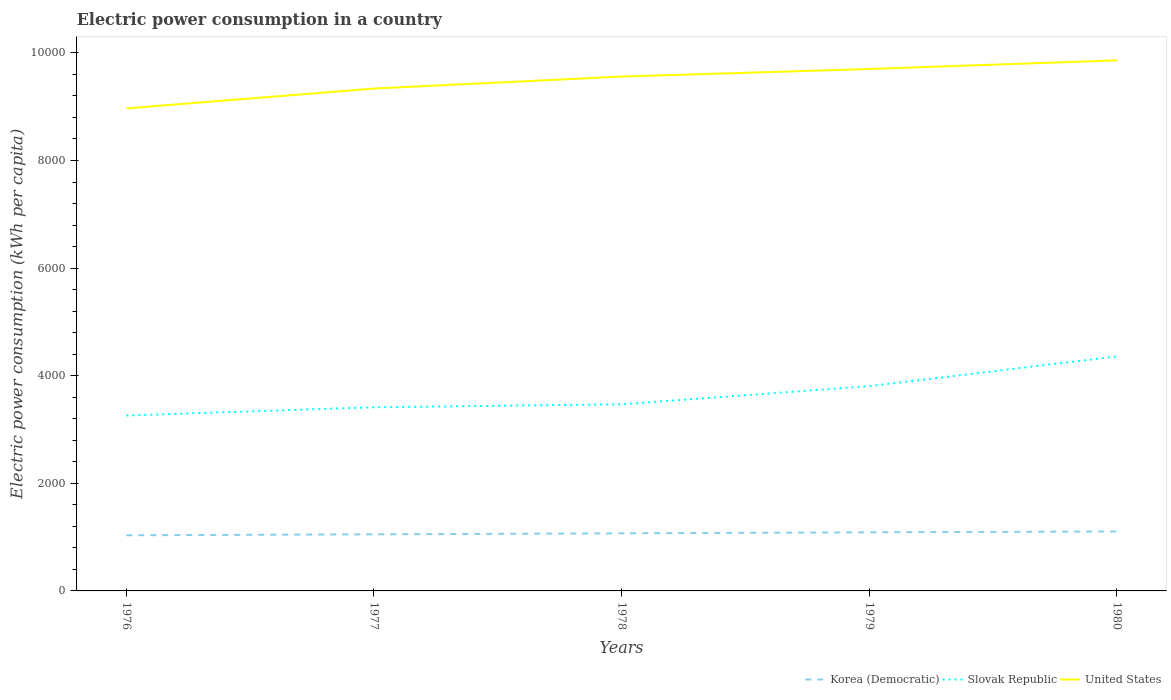How many different coloured lines are there?
Provide a succinct answer. 3. Across all years, what is the maximum electric power consumption in in Slovak Republic?
Your answer should be very brief. 3260.46. In which year was the electric power consumption in in Slovak Republic maximum?
Offer a very short reply. 1976. What is the total electric power consumption in in United States in the graph?
Provide a succinct answer. -368.95. What is the difference between the highest and the second highest electric power consumption in in Korea (Democratic)?
Give a very brief answer. 71.05. Is the electric power consumption in in Korea (Democratic) strictly greater than the electric power consumption in in United States over the years?
Offer a very short reply. Yes. Where does the legend appear in the graph?
Your answer should be compact. Bottom right. What is the title of the graph?
Offer a very short reply. Electric power consumption in a country. What is the label or title of the X-axis?
Your answer should be compact. Years. What is the label or title of the Y-axis?
Your answer should be very brief. Electric power consumption (kWh per capita). What is the Electric power consumption (kWh per capita) in Korea (Democratic) in 1976?
Provide a succinct answer. 1034.22. What is the Electric power consumption (kWh per capita) in Slovak Republic in 1976?
Offer a very short reply. 3260.46. What is the Electric power consumption (kWh per capita) in United States in 1976?
Provide a short and direct response. 8968.78. What is the Electric power consumption (kWh per capita) of Korea (Democratic) in 1977?
Your answer should be very brief. 1052.04. What is the Electric power consumption (kWh per capita) of Slovak Republic in 1977?
Offer a terse response. 3413.49. What is the Electric power consumption (kWh per capita) in United States in 1977?
Provide a succinct answer. 9337.72. What is the Electric power consumption (kWh per capita) in Korea (Democratic) in 1978?
Offer a terse response. 1070.92. What is the Electric power consumption (kWh per capita) in Slovak Republic in 1978?
Your response must be concise. 3468.62. What is the Electric power consumption (kWh per capita) in United States in 1978?
Your answer should be very brief. 9560.55. What is the Electric power consumption (kWh per capita) of Korea (Democratic) in 1979?
Offer a terse response. 1089.3. What is the Electric power consumption (kWh per capita) in Slovak Republic in 1979?
Ensure brevity in your answer.  3806.46. What is the Electric power consumption (kWh per capita) in United States in 1979?
Make the answer very short. 9700.7. What is the Electric power consumption (kWh per capita) in Korea (Democratic) in 1980?
Ensure brevity in your answer.  1105.27. What is the Electric power consumption (kWh per capita) in Slovak Republic in 1980?
Offer a terse response. 4358.6. What is the Electric power consumption (kWh per capita) of United States in 1980?
Ensure brevity in your answer.  9862.37. Across all years, what is the maximum Electric power consumption (kWh per capita) of Korea (Democratic)?
Provide a succinct answer. 1105.27. Across all years, what is the maximum Electric power consumption (kWh per capita) of Slovak Republic?
Keep it short and to the point. 4358.6. Across all years, what is the maximum Electric power consumption (kWh per capita) of United States?
Your answer should be very brief. 9862.37. Across all years, what is the minimum Electric power consumption (kWh per capita) in Korea (Democratic)?
Ensure brevity in your answer.  1034.22. Across all years, what is the minimum Electric power consumption (kWh per capita) of Slovak Republic?
Make the answer very short. 3260.46. Across all years, what is the minimum Electric power consumption (kWh per capita) of United States?
Keep it short and to the point. 8968.78. What is the total Electric power consumption (kWh per capita) of Korea (Democratic) in the graph?
Make the answer very short. 5351.76. What is the total Electric power consumption (kWh per capita) in Slovak Republic in the graph?
Provide a succinct answer. 1.83e+04. What is the total Electric power consumption (kWh per capita) in United States in the graph?
Offer a terse response. 4.74e+04. What is the difference between the Electric power consumption (kWh per capita) of Korea (Democratic) in 1976 and that in 1977?
Keep it short and to the point. -17.82. What is the difference between the Electric power consumption (kWh per capita) in Slovak Republic in 1976 and that in 1977?
Provide a succinct answer. -153.03. What is the difference between the Electric power consumption (kWh per capita) in United States in 1976 and that in 1977?
Provide a succinct answer. -368.95. What is the difference between the Electric power consumption (kWh per capita) in Korea (Democratic) in 1976 and that in 1978?
Ensure brevity in your answer.  -36.7. What is the difference between the Electric power consumption (kWh per capita) in Slovak Republic in 1976 and that in 1978?
Your answer should be compact. -208.16. What is the difference between the Electric power consumption (kWh per capita) in United States in 1976 and that in 1978?
Offer a terse response. -591.77. What is the difference between the Electric power consumption (kWh per capita) of Korea (Democratic) in 1976 and that in 1979?
Offer a very short reply. -55.08. What is the difference between the Electric power consumption (kWh per capita) of Slovak Republic in 1976 and that in 1979?
Offer a terse response. -546. What is the difference between the Electric power consumption (kWh per capita) of United States in 1976 and that in 1979?
Make the answer very short. -731.92. What is the difference between the Electric power consumption (kWh per capita) of Korea (Democratic) in 1976 and that in 1980?
Offer a terse response. -71.05. What is the difference between the Electric power consumption (kWh per capita) of Slovak Republic in 1976 and that in 1980?
Offer a terse response. -1098.13. What is the difference between the Electric power consumption (kWh per capita) in United States in 1976 and that in 1980?
Ensure brevity in your answer.  -893.59. What is the difference between the Electric power consumption (kWh per capita) of Korea (Democratic) in 1977 and that in 1978?
Keep it short and to the point. -18.88. What is the difference between the Electric power consumption (kWh per capita) in Slovak Republic in 1977 and that in 1978?
Ensure brevity in your answer.  -55.13. What is the difference between the Electric power consumption (kWh per capita) of United States in 1977 and that in 1978?
Your answer should be very brief. -222.82. What is the difference between the Electric power consumption (kWh per capita) of Korea (Democratic) in 1977 and that in 1979?
Keep it short and to the point. -37.26. What is the difference between the Electric power consumption (kWh per capita) in Slovak Republic in 1977 and that in 1979?
Ensure brevity in your answer.  -392.97. What is the difference between the Electric power consumption (kWh per capita) of United States in 1977 and that in 1979?
Your answer should be very brief. -362.97. What is the difference between the Electric power consumption (kWh per capita) in Korea (Democratic) in 1977 and that in 1980?
Give a very brief answer. -53.23. What is the difference between the Electric power consumption (kWh per capita) in Slovak Republic in 1977 and that in 1980?
Your response must be concise. -945.11. What is the difference between the Electric power consumption (kWh per capita) of United States in 1977 and that in 1980?
Provide a short and direct response. -524.64. What is the difference between the Electric power consumption (kWh per capita) of Korea (Democratic) in 1978 and that in 1979?
Your answer should be compact. -18.38. What is the difference between the Electric power consumption (kWh per capita) in Slovak Republic in 1978 and that in 1979?
Your answer should be very brief. -337.84. What is the difference between the Electric power consumption (kWh per capita) of United States in 1978 and that in 1979?
Give a very brief answer. -140.15. What is the difference between the Electric power consumption (kWh per capita) in Korea (Democratic) in 1978 and that in 1980?
Give a very brief answer. -34.35. What is the difference between the Electric power consumption (kWh per capita) of Slovak Republic in 1978 and that in 1980?
Make the answer very short. -889.97. What is the difference between the Electric power consumption (kWh per capita) of United States in 1978 and that in 1980?
Give a very brief answer. -301.82. What is the difference between the Electric power consumption (kWh per capita) in Korea (Democratic) in 1979 and that in 1980?
Give a very brief answer. -15.97. What is the difference between the Electric power consumption (kWh per capita) of Slovak Republic in 1979 and that in 1980?
Offer a very short reply. -552.14. What is the difference between the Electric power consumption (kWh per capita) in United States in 1979 and that in 1980?
Offer a terse response. -161.67. What is the difference between the Electric power consumption (kWh per capita) of Korea (Democratic) in 1976 and the Electric power consumption (kWh per capita) of Slovak Republic in 1977?
Keep it short and to the point. -2379.27. What is the difference between the Electric power consumption (kWh per capita) in Korea (Democratic) in 1976 and the Electric power consumption (kWh per capita) in United States in 1977?
Your response must be concise. -8303.5. What is the difference between the Electric power consumption (kWh per capita) of Slovak Republic in 1976 and the Electric power consumption (kWh per capita) of United States in 1977?
Make the answer very short. -6077.26. What is the difference between the Electric power consumption (kWh per capita) of Korea (Democratic) in 1976 and the Electric power consumption (kWh per capita) of Slovak Republic in 1978?
Give a very brief answer. -2434.4. What is the difference between the Electric power consumption (kWh per capita) in Korea (Democratic) in 1976 and the Electric power consumption (kWh per capita) in United States in 1978?
Offer a very short reply. -8526.33. What is the difference between the Electric power consumption (kWh per capita) of Slovak Republic in 1976 and the Electric power consumption (kWh per capita) of United States in 1978?
Keep it short and to the point. -6300.08. What is the difference between the Electric power consumption (kWh per capita) of Korea (Democratic) in 1976 and the Electric power consumption (kWh per capita) of Slovak Republic in 1979?
Your answer should be compact. -2772.24. What is the difference between the Electric power consumption (kWh per capita) in Korea (Democratic) in 1976 and the Electric power consumption (kWh per capita) in United States in 1979?
Provide a succinct answer. -8666.48. What is the difference between the Electric power consumption (kWh per capita) of Slovak Republic in 1976 and the Electric power consumption (kWh per capita) of United States in 1979?
Your response must be concise. -6440.23. What is the difference between the Electric power consumption (kWh per capita) of Korea (Democratic) in 1976 and the Electric power consumption (kWh per capita) of Slovak Republic in 1980?
Your answer should be very brief. -3324.38. What is the difference between the Electric power consumption (kWh per capita) of Korea (Democratic) in 1976 and the Electric power consumption (kWh per capita) of United States in 1980?
Provide a succinct answer. -8828.15. What is the difference between the Electric power consumption (kWh per capita) of Slovak Republic in 1976 and the Electric power consumption (kWh per capita) of United States in 1980?
Your response must be concise. -6601.9. What is the difference between the Electric power consumption (kWh per capita) of Korea (Democratic) in 1977 and the Electric power consumption (kWh per capita) of Slovak Republic in 1978?
Your answer should be compact. -2416.58. What is the difference between the Electric power consumption (kWh per capita) in Korea (Democratic) in 1977 and the Electric power consumption (kWh per capita) in United States in 1978?
Your answer should be compact. -8508.5. What is the difference between the Electric power consumption (kWh per capita) of Slovak Republic in 1977 and the Electric power consumption (kWh per capita) of United States in 1978?
Your response must be concise. -6147.06. What is the difference between the Electric power consumption (kWh per capita) in Korea (Democratic) in 1977 and the Electric power consumption (kWh per capita) in Slovak Republic in 1979?
Make the answer very short. -2754.42. What is the difference between the Electric power consumption (kWh per capita) in Korea (Democratic) in 1977 and the Electric power consumption (kWh per capita) in United States in 1979?
Make the answer very short. -8648.65. What is the difference between the Electric power consumption (kWh per capita) in Slovak Republic in 1977 and the Electric power consumption (kWh per capita) in United States in 1979?
Your answer should be compact. -6287.21. What is the difference between the Electric power consumption (kWh per capita) in Korea (Democratic) in 1977 and the Electric power consumption (kWh per capita) in Slovak Republic in 1980?
Offer a terse response. -3306.55. What is the difference between the Electric power consumption (kWh per capita) of Korea (Democratic) in 1977 and the Electric power consumption (kWh per capita) of United States in 1980?
Keep it short and to the point. -8810.32. What is the difference between the Electric power consumption (kWh per capita) in Slovak Republic in 1977 and the Electric power consumption (kWh per capita) in United States in 1980?
Keep it short and to the point. -6448.88. What is the difference between the Electric power consumption (kWh per capita) in Korea (Democratic) in 1978 and the Electric power consumption (kWh per capita) in Slovak Republic in 1979?
Your response must be concise. -2735.54. What is the difference between the Electric power consumption (kWh per capita) in Korea (Democratic) in 1978 and the Electric power consumption (kWh per capita) in United States in 1979?
Your response must be concise. -8629.77. What is the difference between the Electric power consumption (kWh per capita) in Slovak Republic in 1978 and the Electric power consumption (kWh per capita) in United States in 1979?
Your response must be concise. -6232.07. What is the difference between the Electric power consumption (kWh per capita) in Korea (Democratic) in 1978 and the Electric power consumption (kWh per capita) in Slovak Republic in 1980?
Offer a terse response. -3287.67. What is the difference between the Electric power consumption (kWh per capita) of Korea (Democratic) in 1978 and the Electric power consumption (kWh per capita) of United States in 1980?
Your answer should be very brief. -8791.44. What is the difference between the Electric power consumption (kWh per capita) in Slovak Republic in 1978 and the Electric power consumption (kWh per capita) in United States in 1980?
Make the answer very short. -6393.74. What is the difference between the Electric power consumption (kWh per capita) in Korea (Democratic) in 1979 and the Electric power consumption (kWh per capita) in Slovak Republic in 1980?
Provide a short and direct response. -3269.29. What is the difference between the Electric power consumption (kWh per capita) of Korea (Democratic) in 1979 and the Electric power consumption (kWh per capita) of United States in 1980?
Give a very brief answer. -8773.06. What is the difference between the Electric power consumption (kWh per capita) in Slovak Republic in 1979 and the Electric power consumption (kWh per capita) in United States in 1980?
Ensure brevity in your answer.  -6055.91. What is the average Electric power consumption (kWh per capita) of Korea (Democratic) per year?
Keep it short and to the point. 1070.35. What is the average Electric power consumption (kWh per capita) of Slovak Republic per year?
Ensure brevity in your answer.  3661.53. What is the average Electric power consumption (kWh per capita) in United States per year?
Offer a terse response. 9486.02. In the year 1976, what is the difference between the Electric power consumption (kWh per capita) in Korea (Democratic) and Electric power consumption (kWh per capita) in Slovak Republic?
Your answer should be compact. -2226.24. In the year 1976, what is the difference between the Electric power consumption (kWh per capita) of Korea (Democratic) and Electric power consumption (kWh per capita) of United States?
Ensure brevity in your answer.  -7934.56. In the year 1976, what is the difference between the Electric power consumption (kWh per capita) in Slovak Republic and Electric power consumption (kWh per capita) in United States?
Your answer should be compact. -5708.31. In the year 1977, what is the difference between the Electric power consumption (kWh per capita) in Korea (Democratic) and Electric power consumption (kWh per capita) in Slovak Republic?
Your answer should be very brief. -2361.45. In the year 1977, what is the difference between the Electric power consumption (kWh per capita) in Korea (Democratic) and Electric power consumption (kWh per capita) in United States?
Keep it short and to the point. -8285.68. In the year 1977, what is the difference between the Electric power consumption (kWh per capita) in Slovak Republic and Electric power consumption (kWh per capita) in United States?
Provide a succinct answer. -5924.23. In the year 1978, what is the difference between the Electric power consumption (kWh per capita) in Korea (Democratic) and Electric power consumption (kWh per capita) in Slovak Republic?
Keep it short and to the point. -2397.7. In the year 1978, what is the difference between the Electric power consumption (kWh per capita) of Korea (Democratic) and Electric power consumption (kWh per capita) of United States?
Provide a short and direct response. -8489.62. In the year 1978, what is the difference between the Electric power consumption (kWh per capita) of Slovak Republic and Electric power consumption (kWh per capita) of United States?
Provide a short and direct response. -6091.92. In the year 1979, what is the difference between the Electric power consumption (kWh per capita) of Korea (Democratic) and Electric power consumption (kWh per capita) of Slovak Republic?
Provide a succinct answer. -2717.16. In the year 1979, what is the difference between the Electric power consumption (kWh per capita) of Korea (Democratic) and Electric power consumption (kWh per capita) of United States?
Ensure brevity in your answer.  -8611.39. In the year 1979, what is the difference between the Electric power consumption (kWh per capita) in Slovak Republic and Electric power consumption (kWh per capita) in United States?
Your answer should be very brief. -5894.24. In the year 1980, what is the difference between the Electric power consumption (kWh per capita) in Korea (Democratic) and Electric power consumption (kWh per capita) in Slovak Republic?
Make the answer very short. -3253.32. In the year 1980, what is the difference between the Electric power consumption (kWh per capita) of Korea (Democratic) and Electric power consumption (kWh per capita) of United States?
Your answer should be very brief. -8757.09. In the year 1980, what is the difference between the Electric power consumption (kWh per capita) in Slovak Republic and Electric power consumption (kWh per capita) in United States?
Provide a succinct answer. -5503.77. What is the ratio of the Electric power consumption (kWh per capita) in Korea (Democratic) in 1976 to that in 1977?
Your answer should be very brief. 0.98. What is the ratio of the Electric power consumption (kWh per capita) in Slovak Republic in 1976 to that in 1977?
Your answer should be very brief. 0.96. What is the ratio of the Electric power consumption (kWh per capita) of United States in 1976 to that in 1977?
Your answer should be compact. 0.96. What is the ratio of the Electric power consumption (kWh per capita) of Korea (Democratic) in 1976 to that in 1978?
Make the answer very short. 0.97. What is the ratio of the Electric power consumption (kWh per capita) in United States in 1976 to that in 1978?
Make the answer very short. 0.94. What is the ratio of the Electric power consumption (kWh per capita) in Korea (Democratic) in 1976 to that in 1979?
Provide a short and direct response. 0.95. What is the ratio of the Electric power consumption (kWh per capita) of Slovak Republic in 1976 to that in 1979?
Ensure brevity in your answer.  0.86. What is the ratio of the Electric power consumption (kWh per capita) of United States in 1976 to that in 1979?
Provide a succinct answer. 0.92. What is the ratio of the Electric power consumption (kWh per capita) of Korea (Democratic) in 1976 to that in 1980?
Make the answer very short. 0.94. What is the ratio of the Electric power consumption (kWh per capita) in Slovak Republic in 1976 to that in 1980?
Keep it short and to the point. 0.75. What is the ratio of the Electric power consumption (kWh per capita) of United States in 1976 to that in 1980?
Keep it short and to the point. 0.91. What is the ratio of the Electric power consumption (kWh per capita) in Korea (Democratic) in 1977 to that in 1978?
Your answer should be very brief. 0.98. What is the ratio of the Electric power consumption (kWh per capita) of Slovak Republic in 1977 to that in 1978?
Your response must be concise. 0.98. What is the ratio of the Electric power consumption (kWh per capita) in United States in 1977 to that in 1978?
Ensure brevity in your answer.  0.98. What is the ratio of the Electric power consumption (kWh per capita) of Korea (Democratic) in 1977 to that in 1979?
Offer a terse response. 0.97. What is the ratio of the Electric power consumption (kWh per capita) of Slovak Republic in 1977 to that in 1979?
Offer a terse response. 0.9. What is the ratio of the Electric power consumption (kWh per capita) of United States in 1977 to that in 1979?
Provide a short and direct response. 0.96. What is the ratio of the Electric power consumption (kWh per capita) of Korea (Democratic) in 1977 to that in 1980?
Offer a terse response. 0.95. What is the ratio of the Electric power consumption (kWh per capita) of Slovak Republic in 1977 to that in 1980?
Your answer should be compact. 0.78. What is the ratio of the Electric power consumption (kWh per capita) in United States in 1977 to that in 1980?
Give a very brief answer. 0.95. What is the ratio of the Electric power consumption (kWh per capita) of Korea (Democratic) in 1978 to that in 1979?
Keep it short and to the point. 0.98. What is the ratio of the Electric power consumption (kWh per capita) of Slovak Republic in 1978 to that in 1979?
Your response must be concise. 0.91. What is the ratio of the Electric power consumption (kWh per capita) in United States in 1978 to that in 1979?
Ensure brevity in your answer.  0.99. What is the ratio of the Electric power consumption (kWh per capita) in Korea (Democratic) in 1978 to that in 1980?
Keep it short and to the point. 0.97. What is the ratio of the Electric power consumption (kWh per capita) in Slovak Republic in 1978 to that in 1980?
Offer a very short reply. 0.8. What is the ratio of the Electric power consumption (kWh per capita) of United States in 1978 to that in 1980?
Ensure brevity in your answer.  0.97. What is the ratio of the Electric power consumption (kWh per capita) of Korea (Democratic) in 1979 to that in 1980?
Keep it short and to the point. 0.99. What is the ratio of the Electric power consumption (kWh per capita) in Slovak Republic in 1979 to that in 1980?
Your response must be concise. 0.87. What is the ratio of the Electric power consumption (kWh per capita) in United States in 1979 to that in 1980?
Provide a short and direct response. 0.98. What is the difference between the highest and the second highest Electric power consumption (kWh per capita) of Korea (Democratic)?
Offer a very short reply. 15.97. What is the difference between the highest and the second highest Electric power consumption (kWh per capita) in Slovak Republic?
Provide a succinct answer. 552.14. What is the difference between the highest and the second highest Electric power consumption (kWh per capita) of United States?
Offer a terse response. 161.67. What is the difference between the highest and the lowest Electric power consumption (kWh per capita) in Korea (Democratic)?
Your response must be concise. 71.05. What is the difference between the highest and the lowest Electric power consumption (kWh per capita) of Slovak Republic?
Offer a very short reply. 1098.13. What is the difference between the highest and the lowest Electric power consumption (kWh per capita) of United States?
Your answer should be very brief. 893.59. 